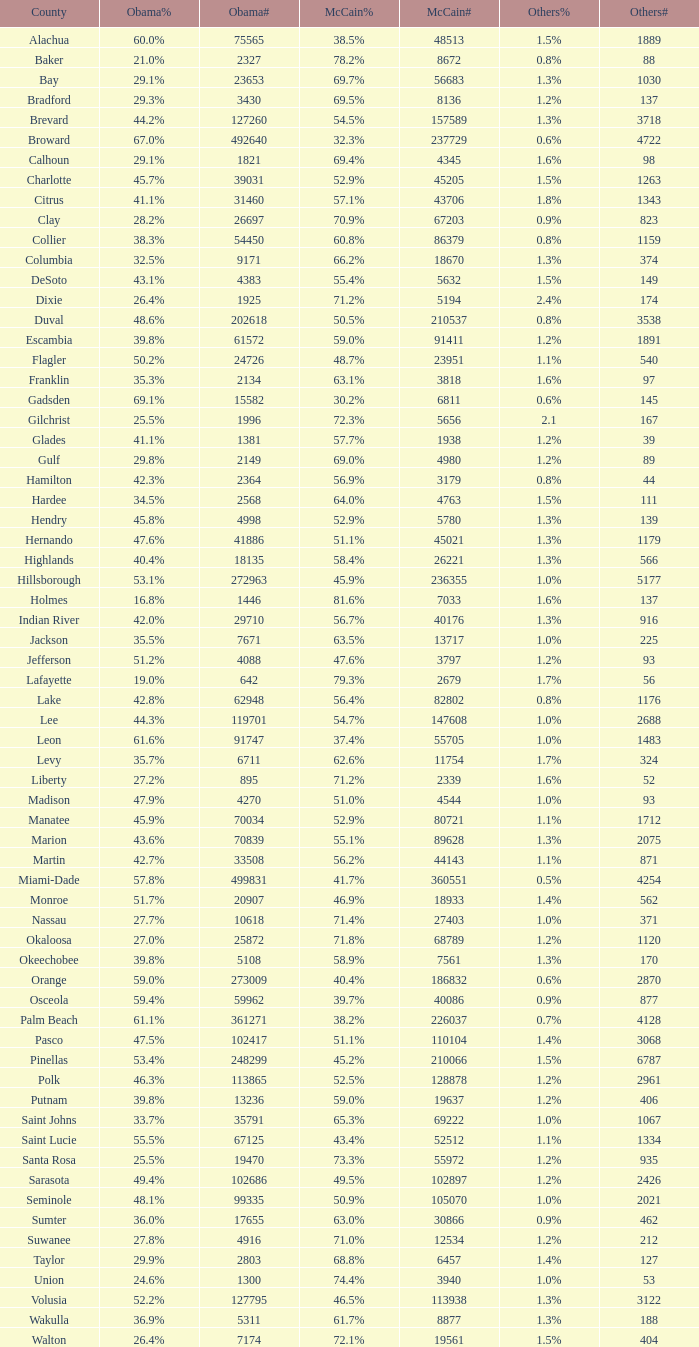0 voters? 1.3%. 